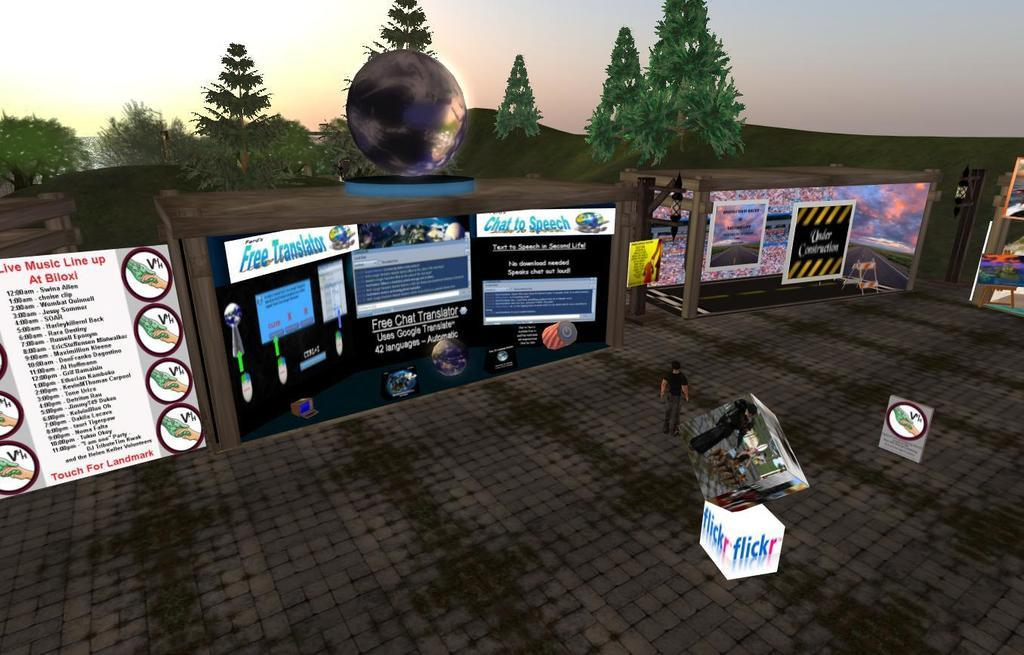What type of image is being described? The image is an animated picture. Can you describe the person in the image? There is a person standing in the image, and they are wearing clothes. What other objects or features can be seen in the image? There are posters, trees, a mountain, a footpath, and the sky is visible in the image. How would you describe the shape of the object in the image? The object is circular in shape. What nation is represented by the toys in the image? There are no toys present in the image, so it is not possible to determine which nation they might represent. 